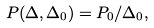Convert formula to latex. <formula><loc_0><loc_0><loc_500><loc_500>P ( \Delta , \Delta _ { 0 } ) = P _ { 0 } / \Delta _ { 0 } ,</formula> 